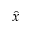<formula> <loc_0><loc_0><loc_500><loc_500>\hat { x }</formula> 